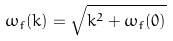<formula> <loc_0><loc_0><loc_500><loc_500>\omega _ { f } ( k ) = \sqrt { k ^ { 2 } + \omega _ { f } ( 0 ) }</formula> 